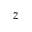Convert formula to latex. <formula><loc_0><loc_0><loc_500><loc_500>z</formula> 